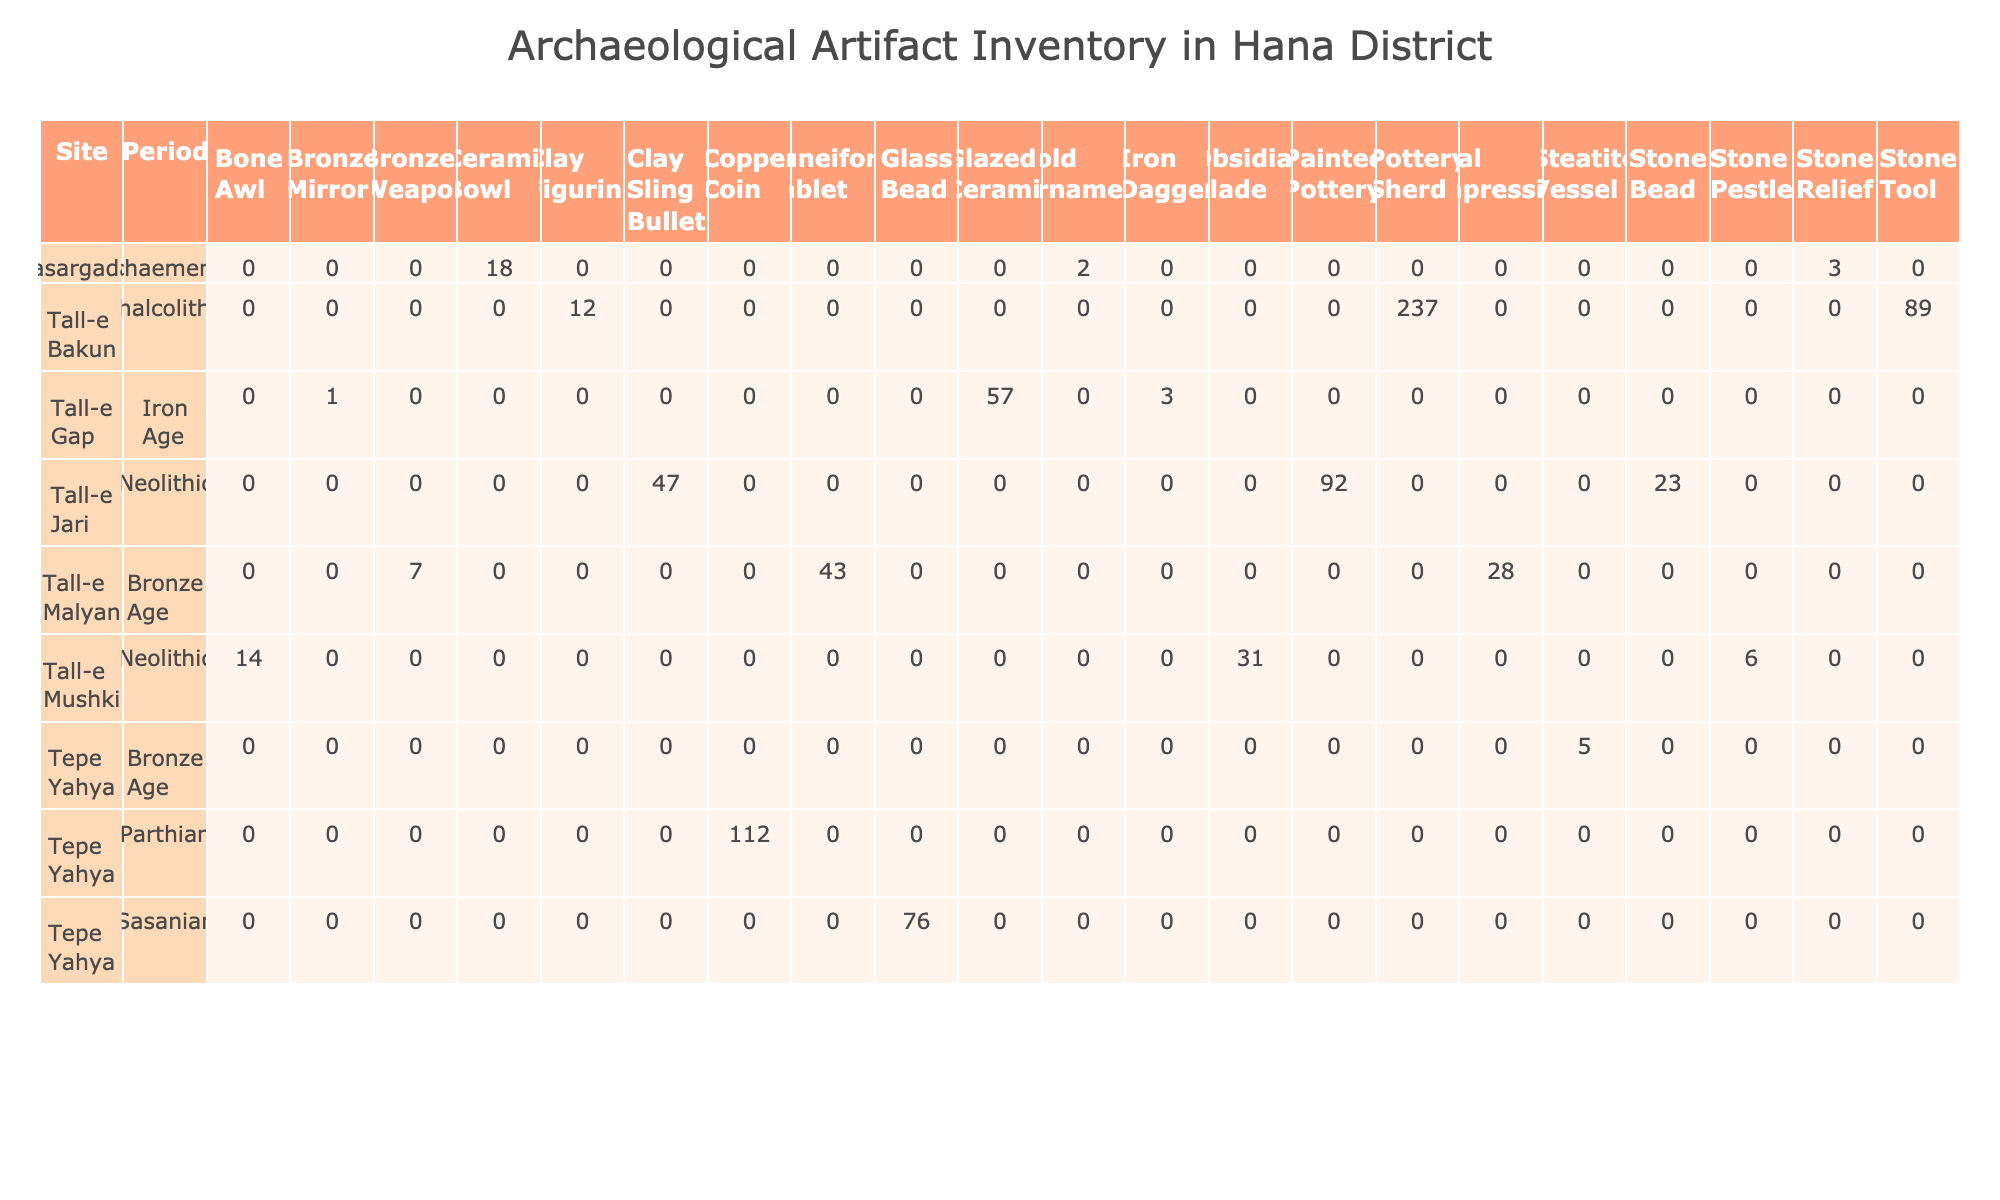What artifact type had the highest quantity discovered in Tall-e Bakun? In Tall-e Bakun, the artifact type with the highest quantity is Pottery Sherd with 237 pieces. This is found by looking at the quantities listed for each artifact type at that site.
Answer: Pottery Sherd How many Clay Figurines were found in total across all sites? The total number of Clay Figurines found is obtained by locating each instance of the Clay Figurine in the table and summing their quantities. Tall-e Bakun has 12 Clay Figurines, and there are no other mentions of this artifact type in the other sites. Therefore, the total is 12.
Answer: 12 Is the Bronze Mirror from Tall-e Gap intact? The condition listed for the Bronze Mirror from Tall-e Gap is 'Corroded', which indicates that it is not in intact condition. A simple check of the condition column for this artifact type confirms this.
Answer: No What is the total quantity of artifacts from the Neolithic period? To find the total quantity of Neolithic artifacts, one would need to sum the quantities of each artifact type listed under the Neolithic period in the pivot table. The quantities are 31 (Obsidian Blade) + 14 (Bone Awl) + 6 (Stone Pestle) + 92 (Painted Pottery) + 47 (Clay Sling Bullet) + 23 (Stone Bead) = 213. Thus, the total quantity is 213.
Answer: 213 Which site has the largest total quantity of artifacts, and what is that amount? To determine which site has the largest total quantity, we need to calculate the sum of quantities for each site. Tall-e Bakun has 237 + 12 + 89 = 338, Tall-e Malyan has 43 + 7 + 28 = 78, Tepe Yahya has 5 + 112 + 76 = 193, Pasargadae has 3 + 2 + 18 = 23, Tall-e Mushki has 31 + 14 + 6 = 51, Tall-e Jari has 92 + 47 + 23 = 162, and Tall-e Gap has 1 + 3 + 57 = 61. The largest total is at Tall-e Bakun with 338 artifacts.
Answer: Tall-e Bakun, 338 